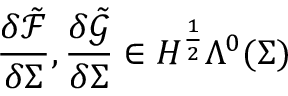Convert formula to latex. <formula><loc_0><loc_0><loc_500><loc_500>\frac { \delta \tilde { \mathcal { F } } } { \delta \Sigma } , \frac { \delta \tilde { \mathcal { G } } } { \delta \Sigma } \in H ^ { \frac { 1 } { 2 } } \Lambda ^ { 0 } ( \Sigma )</formula> 